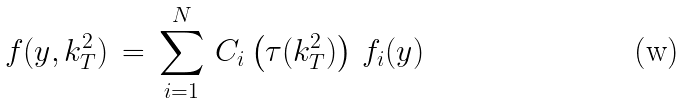Convert formula to latex. <formula><loc_0><loc_0><loc_500><loc_500>f ( y , k _ { T } ^ { 2 } ) \, = \, \sum _ { i = 1 } ^ { N } \, C _ { i } \left ( \tau ( k _ { T } ^ { 2 } ) \right ) \, f _ { i } ( y )</formula> 